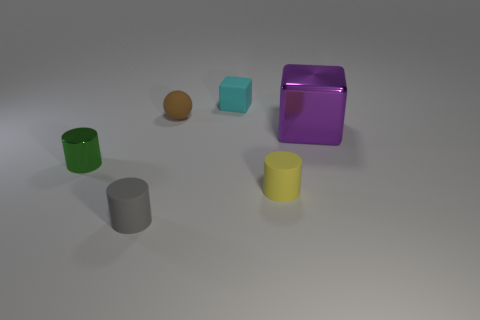Add 4 large metallic cubes. How many objects exist? 10 Subtract all cubes. How many objects are left? 4 Subtract 0 gray cubes. How many objects are left? 6 Subtract all small red matte cylinders. Subtract all tiny metal cylinders. How many objects are left? 5 Add 4 cubes. How many cubes are left? 6 Add 6 small cyan things. How many small cyan things exist? 7 